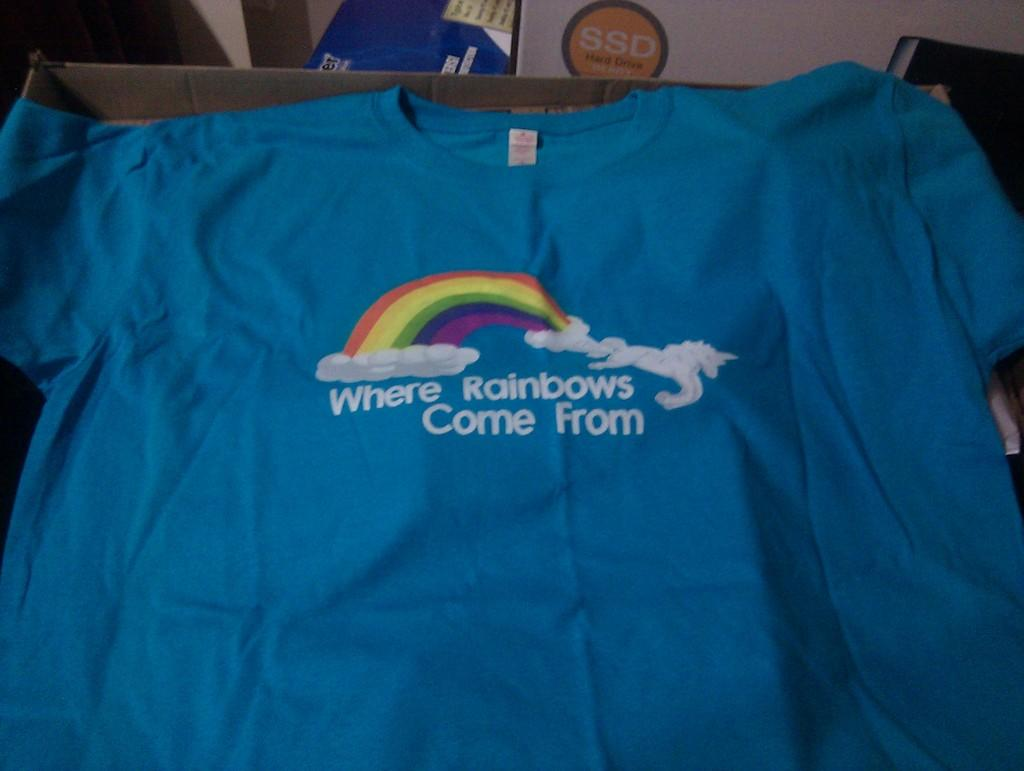<image>
Provide a brief description of the given image. a teal blue shirt with white writing saying where rainbows come from 